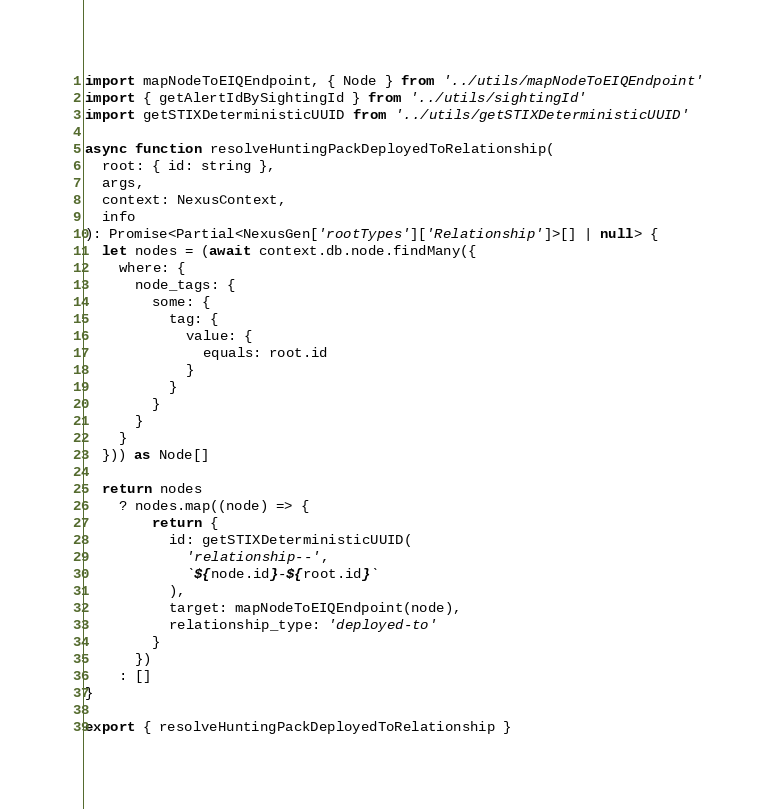<code> <loc_0><loc_0><loc_500><loc_500><_TypeScript_>import mapNodeToEIQEndpoint, { Node } from '../utils/mapNodeToEIQEndpoint'
import { getAlertIdBySightingId } from '../utils/sightingId'
import getSTIXDeterministicUUID from '../utils/getSTIXDeterministicUUID'

async function resolveHuntingPackDeployedToRelationship(
  root: { id: string },
  args,
  context: NexusContext,
  info
): Promise<Partial<NexusGen['rootTypes']['Relationship']>[] | null> {
  let nodes = (await context.db.node.findMany({
    where: {
      node_tags: {
        some: {
          tag: {
            value: {
              equals: root.id
            }
          }
        }
      }
    }
  })) as Node[]

  return nodes
    ? nodes.map((node) => {
        return {
          id: getSTIXDeterministicUUID(
            'relationship--',
            `${node.id}-${root.id}`
          ),
          target: mapNodeToEIQEndpoint(node),
          relationship_type: 'deployed-to'
        }
      })
    : []
}

export { resolveHuntingPackDeployedToRelationship }
</code> 